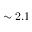<formula> <loc_0><loc_0><loc_500><loc_500>\sim 2 . 1</formula> 